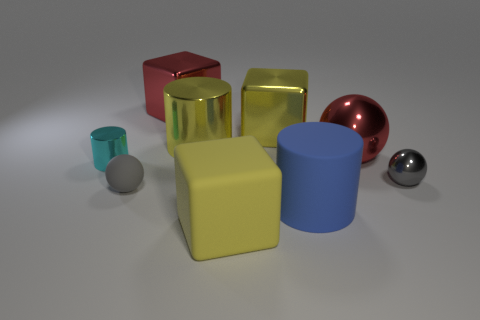Is the number of cyan cylinders in front of the yellow rubber thing the same as the number of cyan cylinders behind the red sphere?
Keep it short and to the point. Yes. What number of tiny gray things are there?
Keep it short and to the point. 2. Is the number of big cylinders that are to the left of the big metallic cylinder greater than the number of small gray spheres?
Make the answer very short. No. There is a big red object to the left of the large yellow shiny cube; what is it made of?
Offer a very short reply. Metal. What color is the other matte object that is the same shape as the cyan thing?
Ensure brevity in your answer.  Blue. What number of small shiny things have the same color as the small matte sphere?
Provide a succinct answer. 1. There is a rubber cube that is in front of the cyan cylinder; does it have the same size as the gray ball behind the tiny matte sphere?
Your answer should be compact. No. Do the yellow matte block and the ball to the left of the big blue rubber thing have the same size?
Give a very brief answer. No. The gray matte thing is what size?
Keep it short and to the point. Small. There is a big ball that is the same material as the cyan thing; what is its color?
Offer a terse response. Red. 